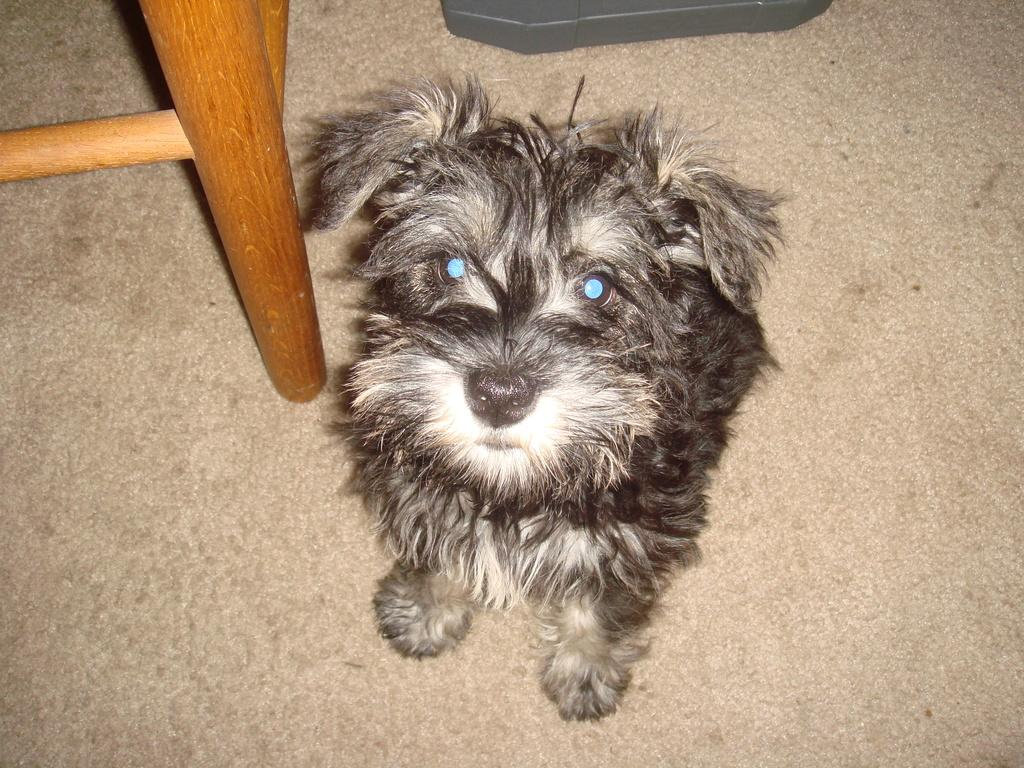What is the main subject in the center of the image? There is a dog in the center of the image. Where is the dog located? The dog is on the floor. What can be seen in the background of the image? There are objects visible in the background of the image. What type of list can be seen hanging on the arch in the image? There is no arch or list present in the image; it features a dog on the floor with objects visible in the background. 